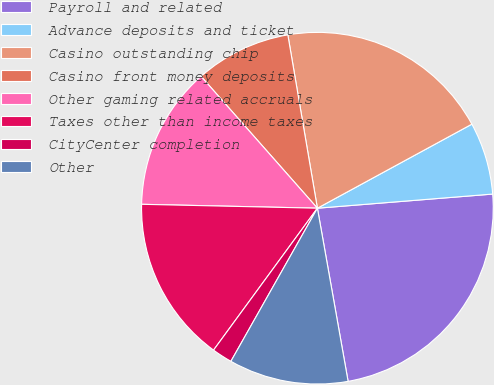Convert chart. <chart><loc_0><loc_0><loc_500><loc_500><pie_chart><fcel>Payroll and related<fcel>Advance deposits and ticket<fcel>Casino outstanding chip<fcel>Casino front money deposits<fcel>Other gaming related accruals<fcel>Taxes other than income taxes<fcel>CityCenter completion<fcel>Other<nl><fcel>23.49%<fcel>6.65%<fcel>19.76%<fcel>8.82%<fcel>13.14%<fcel>15.3%<fcel>1.87%<fcel>10.98%<nl></chart> 